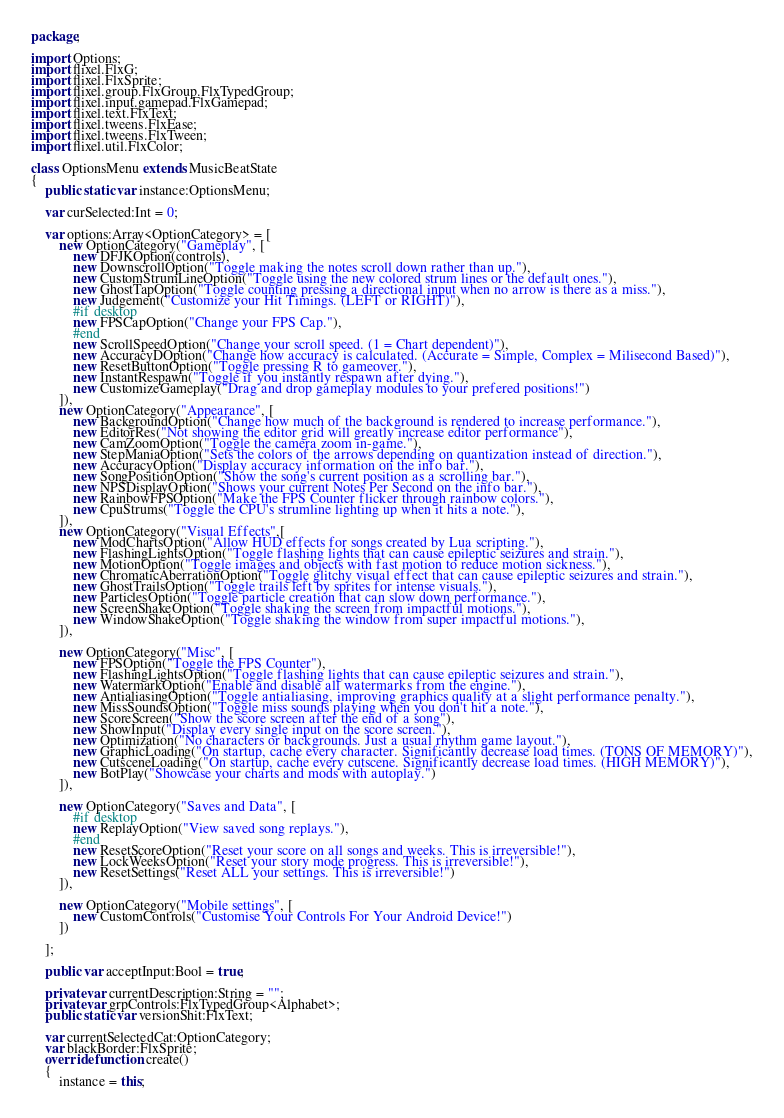<code> <loc_0><loc_0><loc_500><loc_500><_Haxe_>package;

import Options;
import flixel.FlxG;
import flixel.FlxSprite;
import flixel.group.FlxGroup.FlxTypedGroup;
import flixel.input.gamepad.FlxGamepad;
import flixel.text.FlxText;
import flixel.tweens.FlxEase;
import flixel.tweens.FlxTween;
import flixel.util.FlxColor;

class OptionsMenu extends MusicBeatState
{
	public static var instance:OptionsMenu;

	var curSelected:Int = 0;

	var options:Array<OptionCategory> = [
		new OptionCategory("Gameplay", [
			new DFJKOption(controls),
			new DownscrollOption("Toggle making the notes scroll down rather than up."),
			new CustomStrumLineOption("Toggle using the new colored strum lines or the default ones."),
			new GhostTapOption("Toggle counting pressing a directional input when no arrow is there as a miss."),
			new Judgement("Customize your Hit Timings. (LEFT or RIGHT)"),
			#if desktop
			new FPSCapOption("Change your FPS Cap."),
			#end
			new ScrollSpeedOption("Change your scroll speed. (1 = Chart dependent)"),
			new AccuracyDOption("Change how accuracy is calculated. (Accurate = Simple, Complex = Milisecond Based)"),
			new ResetButtonOption("Toggle pressing R to gameover."),
			new InstantRespawn("Toggle if you instantly respawn after dying."),
			new CustomizeGameplay("Drag and drop gameplay modules to your prefered positions!")
		]),
		new OptionCategory("Appearance", [
			new BackgroundOption("Change how much of the background is rendered to increase performance."),
			new EditorRes("Not showing the editor grid will greatly increase editor performance"),
			new CamZoomOption("Toggle the camera zoom in-game."),
			new StepManiaOption("Sets the colors of the arrows depending on quantization instead of direction."),
			new AccuracyOption("Display accuracy information on the info bar."),
			new SongPositionOption("Show the song's current position as a scrolling bar."),
			new NPSDisplayOption("Shows your current Notes Per Second on the info bar."),
			new RainbowFPSOption("Make the FPS Counter flicker through rainbow colors."),
			new CpuStrums("Toggle the CPU's strumline lighting up when it hits a note."),
		]),
		new OptionCategory("Visual Effects",[
			new ModChartsOption("Allow HUD effects for songs created by Lua scripting."),
			new FlashingLightsOption("Toggle flashing lights that can cause epileptic seizures and strain."),
			new MotionOption("Toggle images and objects with fast motion to reduce motion sickness."),
			new ChromaticAberrationOption("Toggle glitchy visual effect that can cause epileptic seizures and strain."),
			new GhostTrailsOption("Toggle trails left by sprites for intense visuals."),
			new ParticlesOption("Toggle particle creation that can slow down performance."),
			new ScreenShakeOption("Toggle shaking the screen from impactful motions."),
			new WindowShakeOption("Toggle shaking the window from super impactful motions."),
		]),

		new OptionCategory("Misc", [
			new FPSOption("Toggle the FPS Counter"),
			new FlashingLightsOption("Toggle flashing lights that can cause epileptic seizures and strain."),
			new WatermarkOption("Enable and disable all watermarks from the engine."),
			new AntialiasingOption("Toggle antialiasing, improving graphics quality at a slight performance penalty."),
			new MissSoundsOption("Toggle miss sounds playing when you don't hit a note."),
			new ScoreScreen("Show the score screen after the end of a song"),
			new ShowInput("Display every single input on the score screen."),
			new Optimization("No characters or backgrounds. Just a usual rhythm game layout."),
			new GraphicLoading("On startup, cache every character. Significantly decrease load times. (TONS OF MEMORY)"),
			new CutsceneLoading("On startup, cache every cutscene. Significantly decrease load times. (HIGH MEMORY)"),
			new BotPlay("Showcase your charts and mods with autoplay.")
		]),

		new OptionCategory("Saves and Data", [
			#if desktop
			new ReplayOption("View saved song replays."),
			#end
			new ResetScoreOption("Reset your score on all songs and weeks. This is irreversible!"),
			new LockWeeksOption("Reset your story mode progress. This is irreversible!"),
			new ResetSettings("Reset ALL your settings. This is irreversible!")
		]),

		new OptionCategory("Mobile settings", [
			new CustomControls("Customise Your Controls For Your Android Device!")
		])

	];

	public var acceptInput:Bool = true;

	private var currentDescription:String = "";
	private var grpControls:FlxTypedGroup<Alphabet>;
	public static var versionShit:FlxText;

	var currentSelectedCat:OptionCategory;
	var blackBorder:FlxSprite;
	override function create()
	{
		instance = this;</code> 